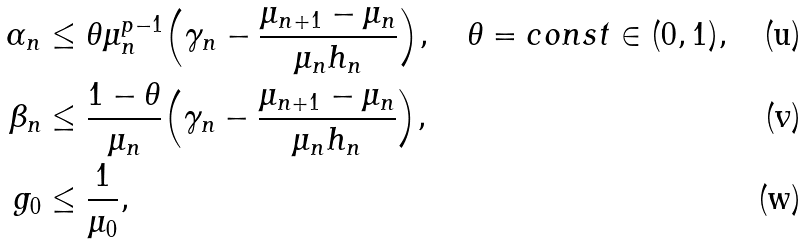Convert formula to latex. <formula><loc_0><loc_0><loc_500><loc_500>\alpha _ { n } & \leq \theta \mu _ { n } ^ { p - 1 } \Big { ( } \gamma _ { n } - \frac { \mu _ { n + 1 } - \mu _ { n } } { \mu _ { n } h _ { n } } \Big { ) } , \quad \theta = c o n s t \in ( 0 , 1 ) , \\ \beta _ { n } & \leq \frac { 1 - \theta } { \mu _ { n } } \Big { ( } \gamma _ { n } - \frac { \mu _ { n + 1 } - \mu _ { n } } { \mu _ { n } h _ { n } } \Big { ) } , \\ g _ { 0 } & \leq \frac { 1 } { \mu _ { 0 } } ,</formula> 